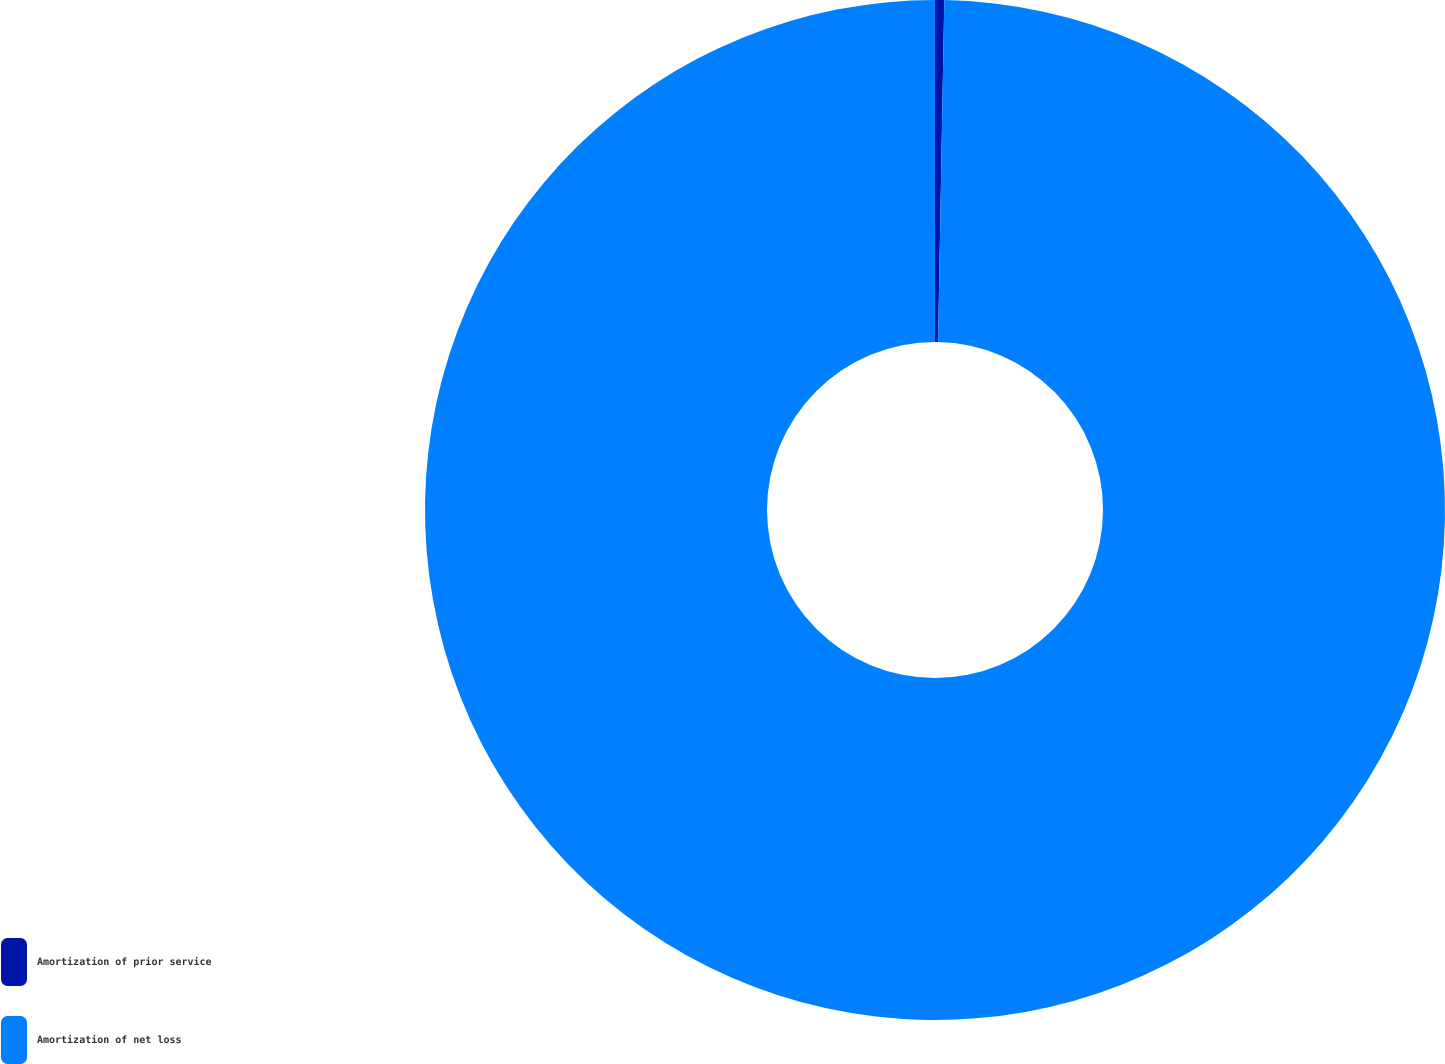<chart> <loc_0><loc_0><loc_500><loc_500><pie_chart><fcel>Amortization of prior service<fcel>Amortization of net loss<nl><fcel>0.29%<fcel>99.71%<nl></chart> 